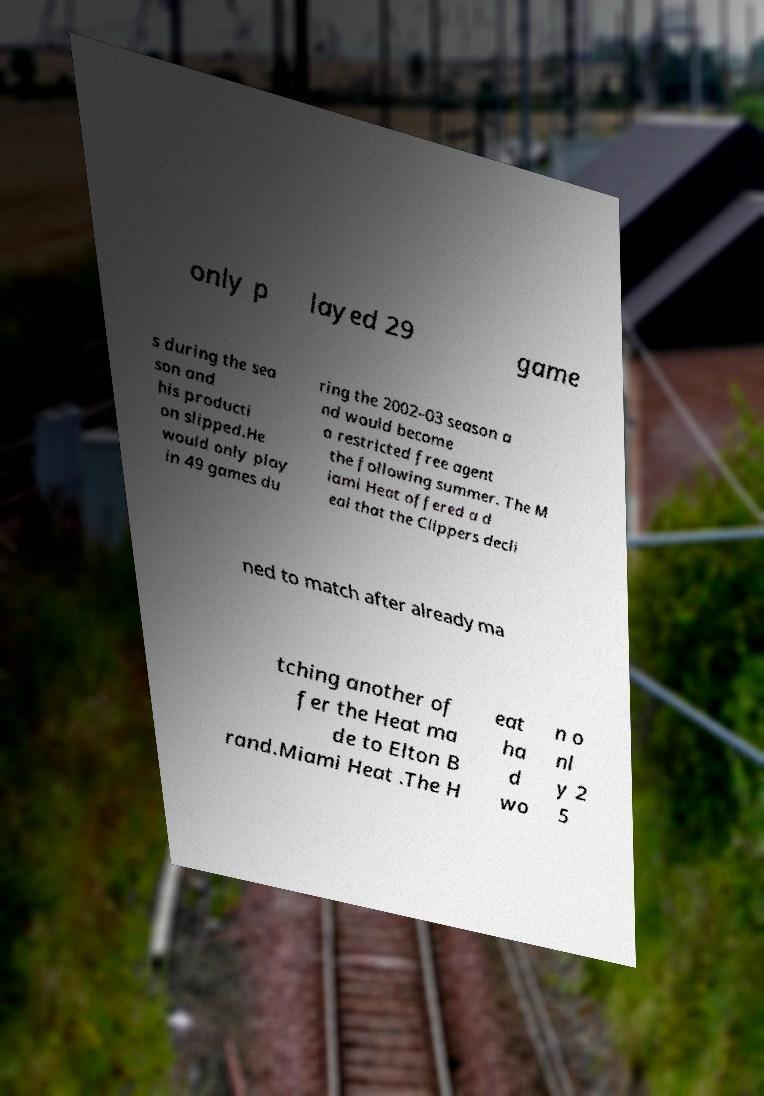I need the written content from this picture converted into text. Can you do that? only p layed 29 game s during the sea son and his producti on slipped.He would only play in 49 games du ring the 2002–03 season a nd would become a restricted free agent the following summer. The M iami Heat offered a d eal that the Clippers decli ned to match after already ma tching another of fer the Heat ma de to Elton B rand.Miami Heat .The H eat ha d wo n o nl y 2 5 